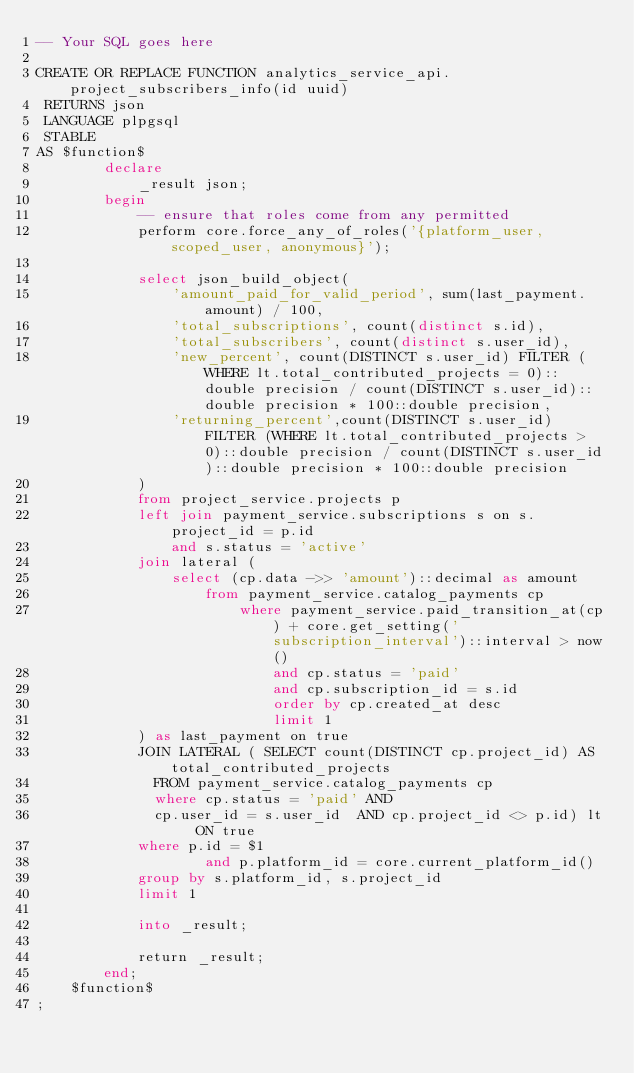Convert code to text. <code><loc_0><loc_0><loc_500><loc_500><_SQL_>-- Your SQL goes here

CREATE OR REPLACE FUNCTION analytics_service_api.project_subscribers_info(id uuid)
 RETURNS json
 LANGUAGE plpgsql
 STABLE
AS $function$
        declare
            _result json;
        begin
            -- ensure that roles come from any permitted
            perform core.force_any_of_roles('{platform_user,scoped_user, anonymous}');
            
            select json_build_object(
                'amount_paid_for_valid_period', sum(last_payment.amount) / 100,
                'total_subscriptions', count(distinct s.id),
                'total_subscribers', count(distinct s.user_id),
                'new_percent', count(DISTINCT s.user_id) FILTER (WHERE lt.total_contributed_projects = 0)::double precision / count(DISTINCT s.user_id)::double precision * 100::double precision,
                'returning_percent',count(DISTINCT s.user_id) FILTER (WHERE lt.total_contributed_projects > 0)::double precision / count(DISTINCT s.user_id)::double precision * 100::double precision
            )
            from project_service.projects p
            left join payment_service.subscriptions s on s.project_id = p.id
                and s.status = 'active'
            join lateral (
                select (cp.data ->> 'amount')::decimal as amount
                    from payment_service.catalog_payments cp
                        where payment_service.paid_transition_at(cp) + core.get_setting('subscription_interval')::interval > now()
                            and cp.status = 'paid'
                            and cp.subscription_id = s.id
                            order by cp.created_at desc
                            limit 1
            ) as last_payment on true
            JOIN LATERAL ( SELECT count(DISTINCT cp.project_id) AS total_contributed_projects
              FROM payment_service.catalog_payments cp
              where cp.status = 'paid' AND
              cp.user_id = s.user_id  AND cp.project_id <> p.id) lt ON true
            where p.id = $1
                    and p.platform_id = core.current_platform_id()
            group by s.platform_id, s.project_id
            limit 1

            into _result;
            
            return _result;
        end;
    $function$
;
</code> 